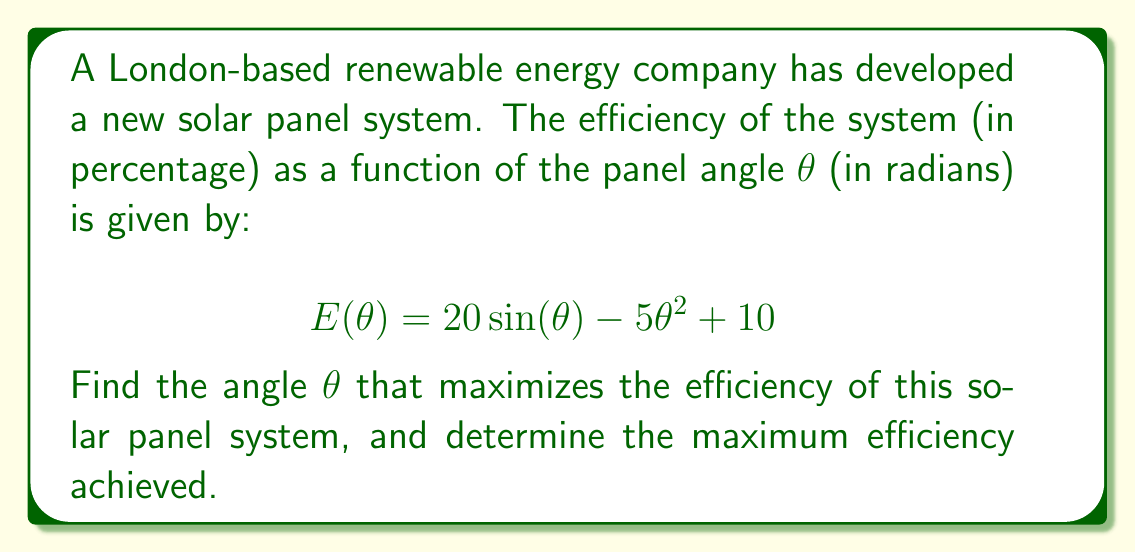Give your solution to this math problem. To find the maximum efficiency point, we need to follow these steps:

1) First, we need to find the derivative of the efficiency function $E(\theta)$:
   $$E'(\theta) = 20\cos(\theta) - 10\theta$$

2) To find the maximum point, we set the derivative equal to zero and solve for $\theta$:
   $$20\cos(\theta) - 10\theta = 0$$
   $$2\cos(\theta) = \theta$$

3) This equation cannot be solved algebraically. We need to use numerical methods or graphical solutions. Using a graphing calculator or computer software, we can find that the solution is approximately:
   $$\theta \approx 1.0293$$

4) To confirm this is a maximum (not a minimum), we can check the second derivative:
   $$E''(\theta) = -20\sin(\theta) - 10$$
   At $\theta \approx 1.0293$, $E''(\theta) < 0$, confirming it's a maximum.

5) To find the maximum efficiency, we substitute this value back into the original function:
   $$E(1.0293) \approx 20\sin(1.0293) - 5(1.0293)^2 + 10 \approx 22.33$$

Therefore, the maximum efficiency is approximately 22.33% when the panel is angled at about 1.0293 radians (or about 59 degrees).
Answer: $\theta \approx 1.0293$ radians, $E_{max} \approx 22.33\%$ 